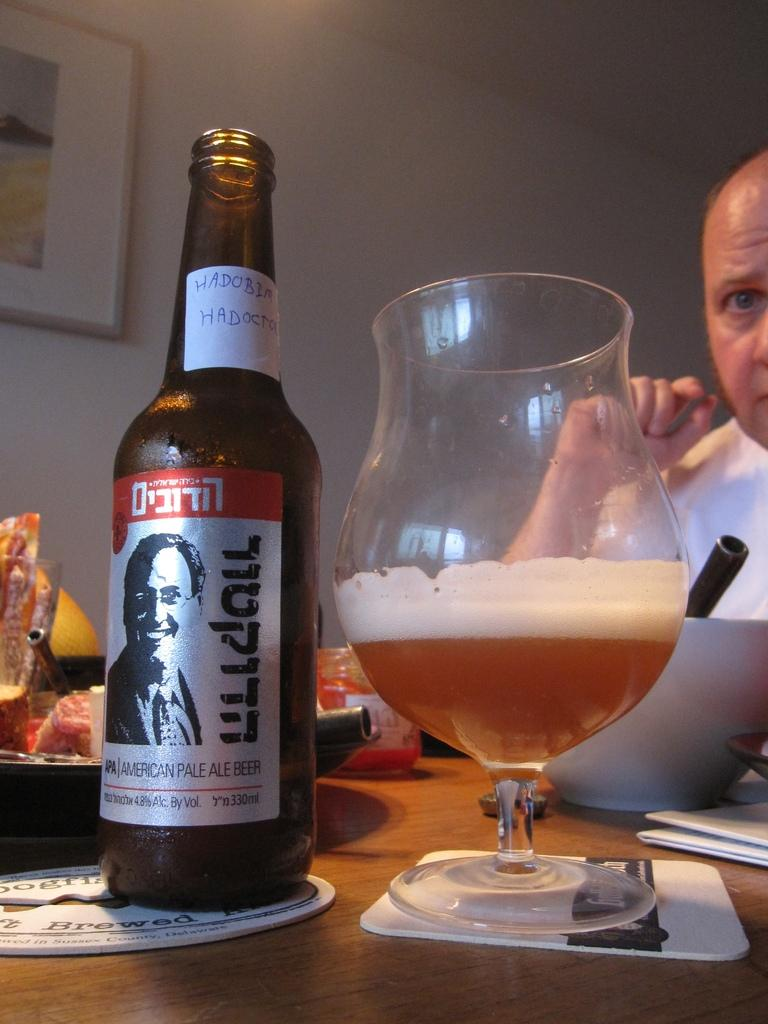<image>
Present a compact description of the photo's key features. Beer from an American Pale Ale Beer bottle is poured into a glass. 